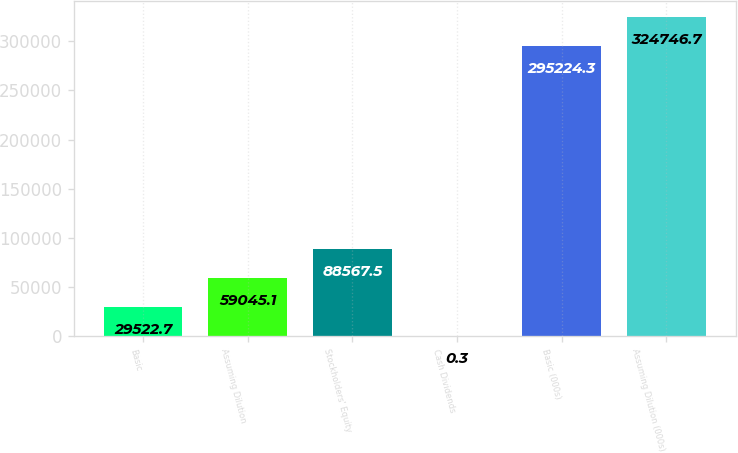Convert chart to OTSL. <chart><loc_0><loc_0><loc_500><loc_500><bar_chart><fcel>Basic<fcel>Assuming Dilution<fcel>Stockholders' Equity<fcel>Cash Dividends<fcel>Basic (000s)<fcel>Assuming Dilution (000s)<nl><fcel>29522.7<fcel>59045.1<fcel>88567.5<fcel>0.3<fcel>295224<fcel>324747<nl></chart> 